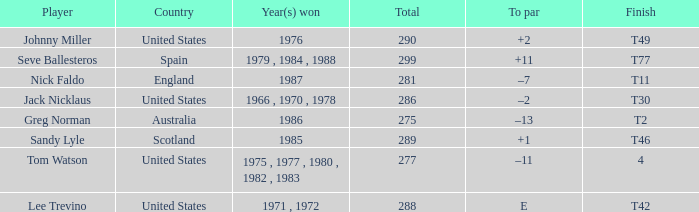What country had a finish of t49? United States. 